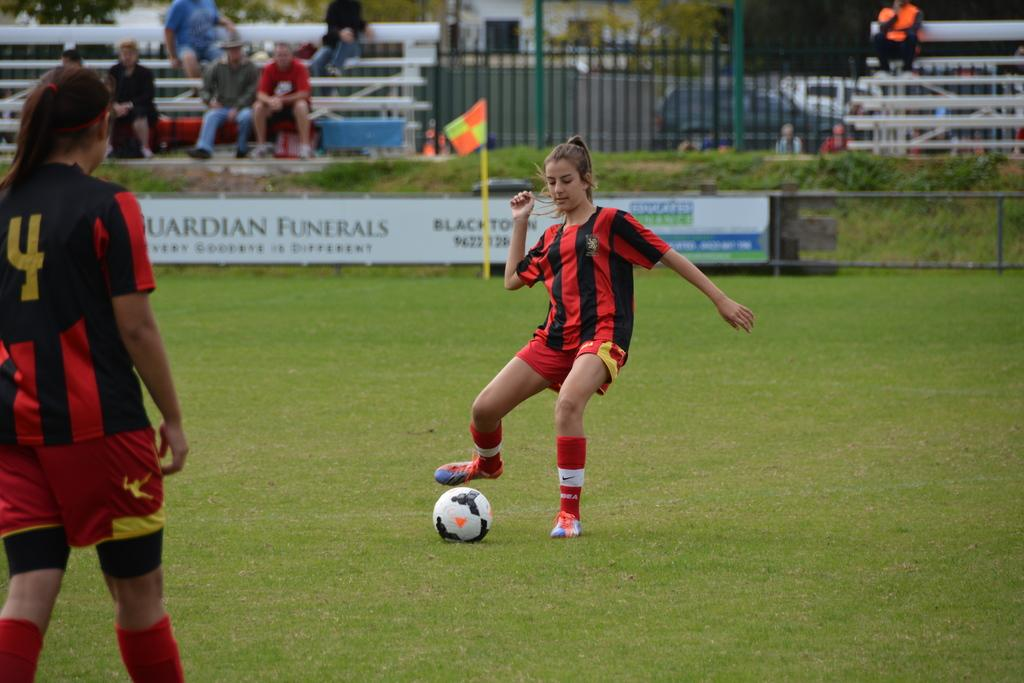Provide a one-sentence caption for the provided image. A soccer game with two women in red and black jersey with one having the number 4 on the back of her jersey. 